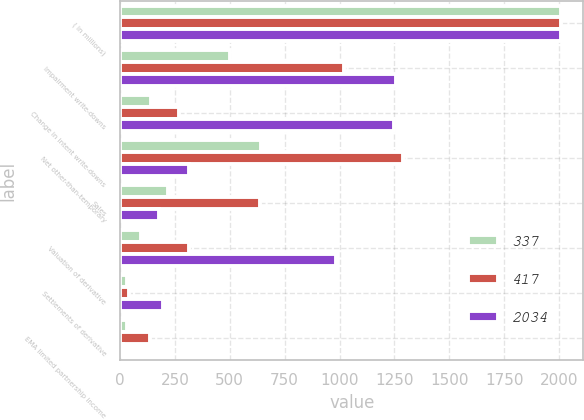Convert chart. <chart><loc_0><loc_0><loc_500><loc_500><stacked_bar_chart><ecel><fcel>( in millions)<fcel>Impairment write-downs<fcel>Change in intent write-downs<fcel>Net other-than-temporary<fcel>Sales<fcel>Valuation of derivative<fcel>Settlements of derivative<fcel>EMA limited partnership income<nl><fcel>337<fcel>2010<fcel>501<fcel>142<fcel>643<fcel>219<fcel>94<fcel>31<fcel>32<nl><fcel>417<fcel>2009<fcel>1021<fcel>268<fcel>1289<fcel>638<fcel>315<fcel>41<fcel>136<nl><fcel>2034<fcel>2008<fcel>1256<fcel>1247<fcel>315<fcel>178<fcel>985<fcel>197<fcel>14<nl></chart> 